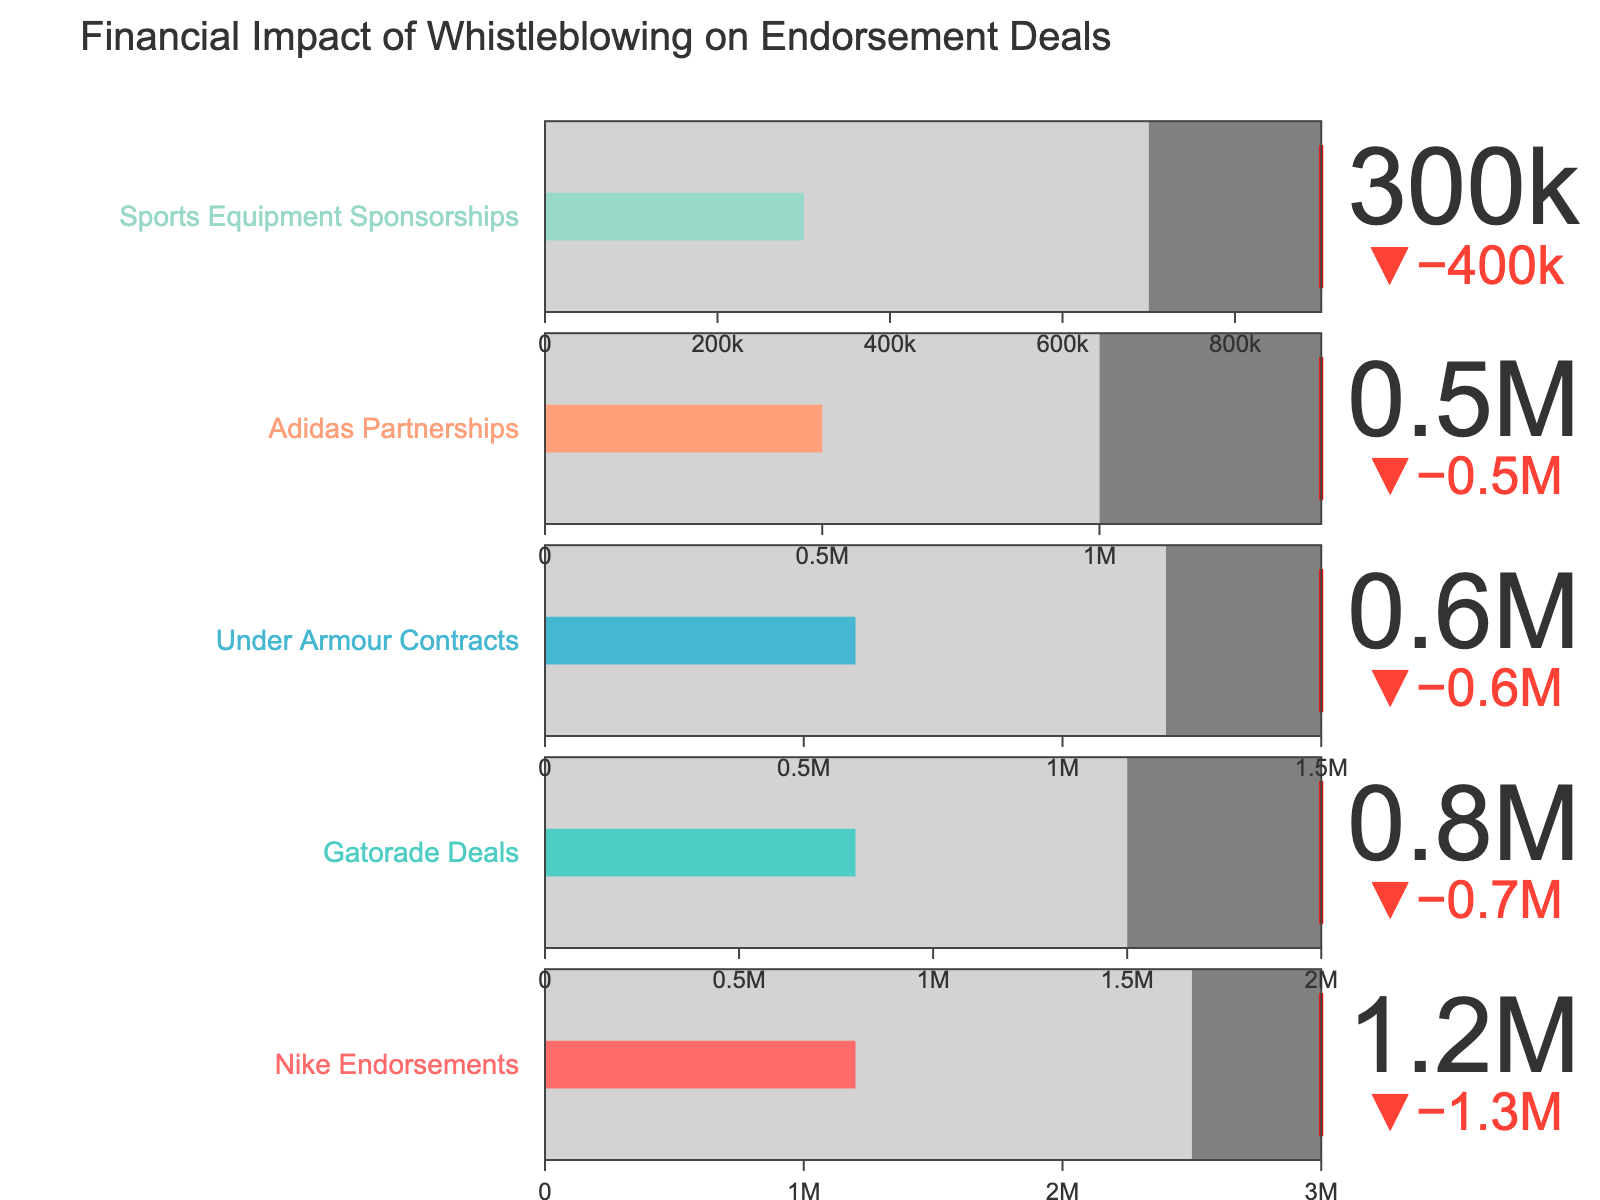What is the title of the chart? The title is at the top of the figure. By reading it, you can identify the title.
Answer: Financial Impact of Whistleblowing on Endorsement Deals How many categories of endorsement deals are represented in the chart? There are rows labeled with different endorsement deals on the y-axis. Counting them gives the total number of categories.
Answer: 5 What is the actual value for Nike Endorsements? Look at the 'Nike Endorsements' row and find the indicator showing the actual value.
Answer: 1,200,000 Which endorsement deal has the greatest difference between the comparative and target values? For each endorsement deal, subtract the comparative value from the target value. Compare these differences to find the largest one.
Answer: Nike Endorsements What is the average actual value of all endorsement deals? Add all the actual values and divide by the number of categories: (1200000 + 800000 + 600000 + 500000 + 300000) / 5.
Answer: 680,000 How does the actual value of Gatorade Deals compare to its comparative value? Compare the actual value (800,000) to the comparative value (1,500,000) for Gatorade Deals.
Answer: It is less than the comparative value Are any of the actual values exceeding their target values? Check if any of the actual values are greater than their corresponding target values.
Answer: No Which category has the lowest actual value, and what is that value? Compare the actual values across all categories and identify the lowest one.
Answer: Sports Equipment Sponsorships, 300,000 What is the range of the target values for all categories? The range is found by subtracting the smallest target value from the largest one: 3,000,000 - 900,000.
Answer: 2,100,000 Based on the visual representation, which category appears closest to reaching its target value? Look for the bullet indicator closest to its target threshold (red line) on the gauge.
Answer: Adidas Partnerships 